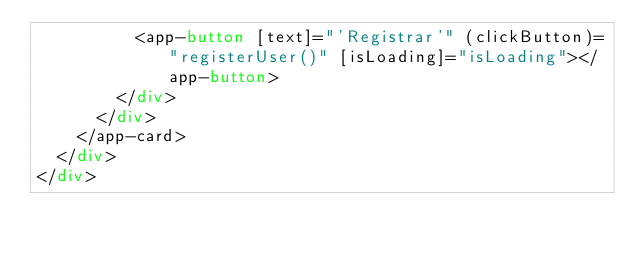Convert code to text. <code><loc_0><loc_0><loc_500><loc_500><_HTML_>          <app-button [text]="'Registrar'" (clickButton)="registerUser()" [isLoading]="isLoading"></app-button>  
        </div>
      </div>
    </app-card>
  </div>
</div></code> 